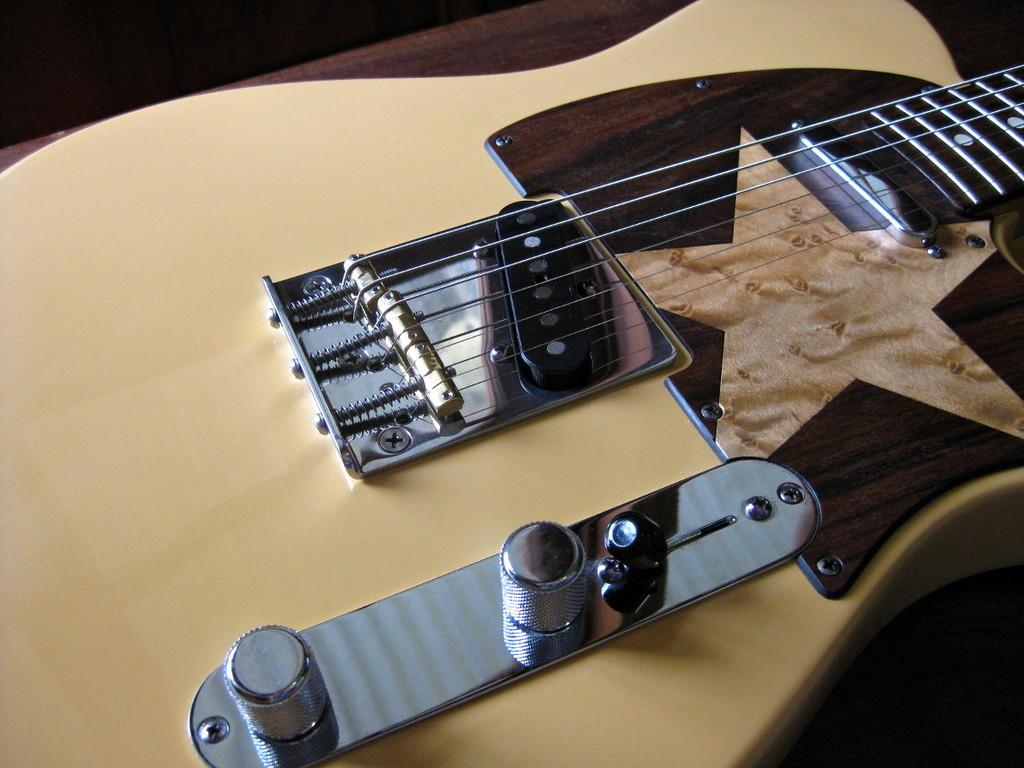What is the main subject of the image? There is a musical instrument in the image. Can you see any popcorn being served at the town festival in the image? There is no reference to popcorn, a town festival, or a rabbit in the image; it only features a musical instrument. 